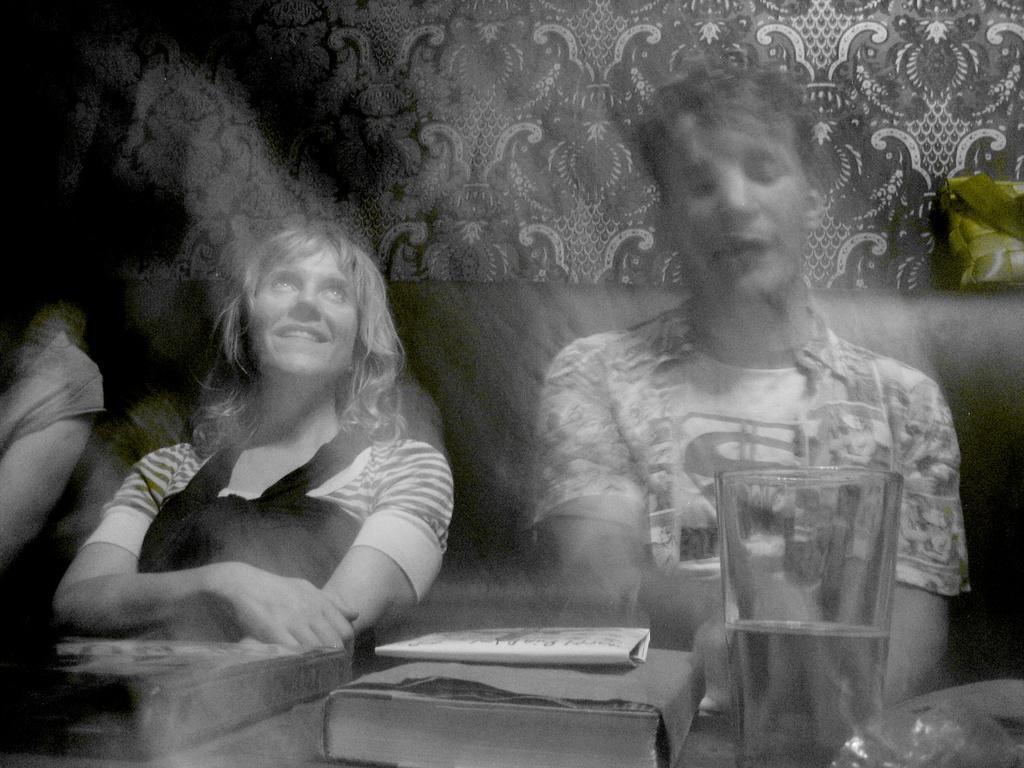Describe this image in one or two sentences. In the picture we can see a man and woman sitting on the sofa near the table on it, we can see a book and a glass of water and in the background we can see a curtain with some designs on it. 